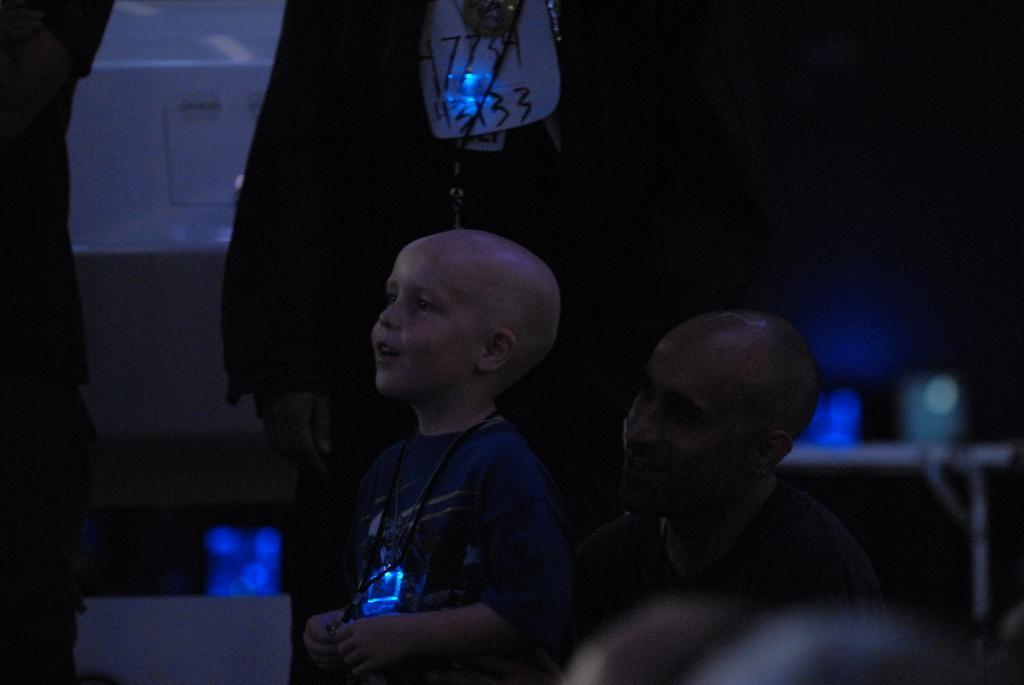Can you describe this image briefly? In the image there is a man and in front of the man and a boy standing and speaking something, behind him there are two people standing and the background of them is blur. 